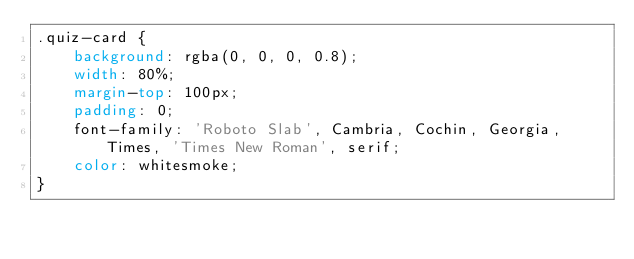Convert code to text. <code><loc_0><loc_0><loc_500><loc_500><_CSS_>.quiz-card {
    background: rgba(0, 0, 0, 0.8);
    width: 80%;
    margin-top: 100px;
    padding: 0;
    font-family: 'Roboto Slab', Cambria, Cochin, Georgia, Times, 'Times New Roman', serif;
    color: whitesmoke;
}
</code> 